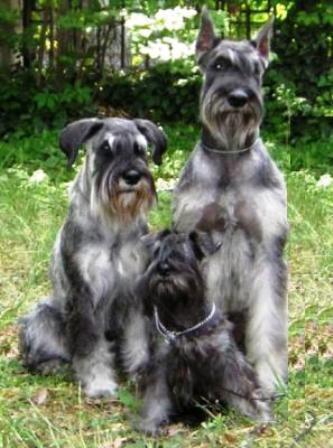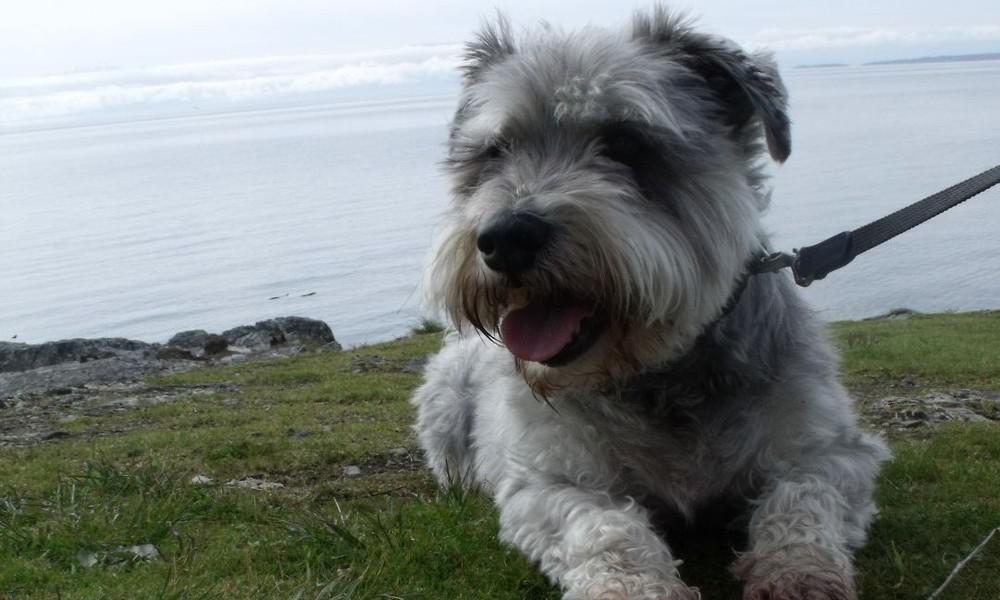The first image is the image on the left, the second image is the image on the right. Evaluate the accuracy of this statement regarding the images: "A person is standing with a group of dogs in the image on the left.". Is it true? Answer yes or no. No. The first image is the image on the left, the second image is the image on the right. Analyze the images presented: Is the assertion "An image shows one schnauzer in the grass, with planted blooming flowers behind the dog but not in front of it." valid? Answer yes or no. No. 